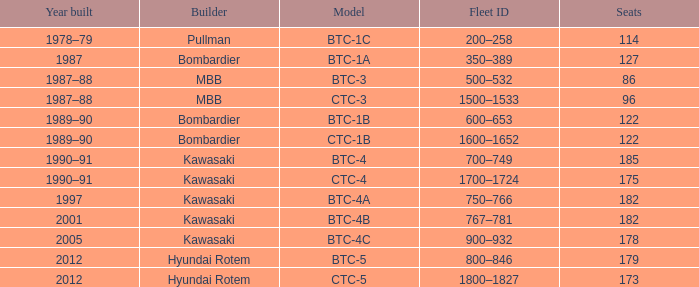In what year was the ctc-3 model developed? 1987–88. 